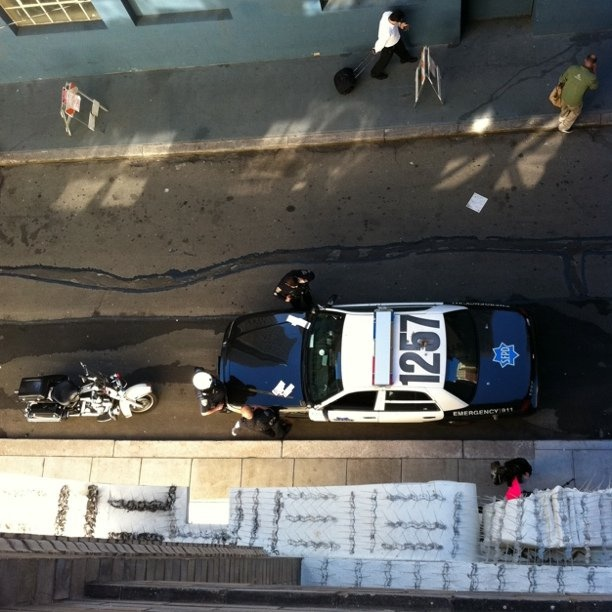Describe the objects in this image and their specific colors. I can see car in olive, black, white, navy, and gray tones, motorcycle in olive, black, ivory, gray, and darkgray tones, people in olive, darkgreen, black, gray, and tan tones, people in olive, black, ivory, darkgray, and gray tones, and people in olive, black, ivory, gray, and darkgray tones in this image. 